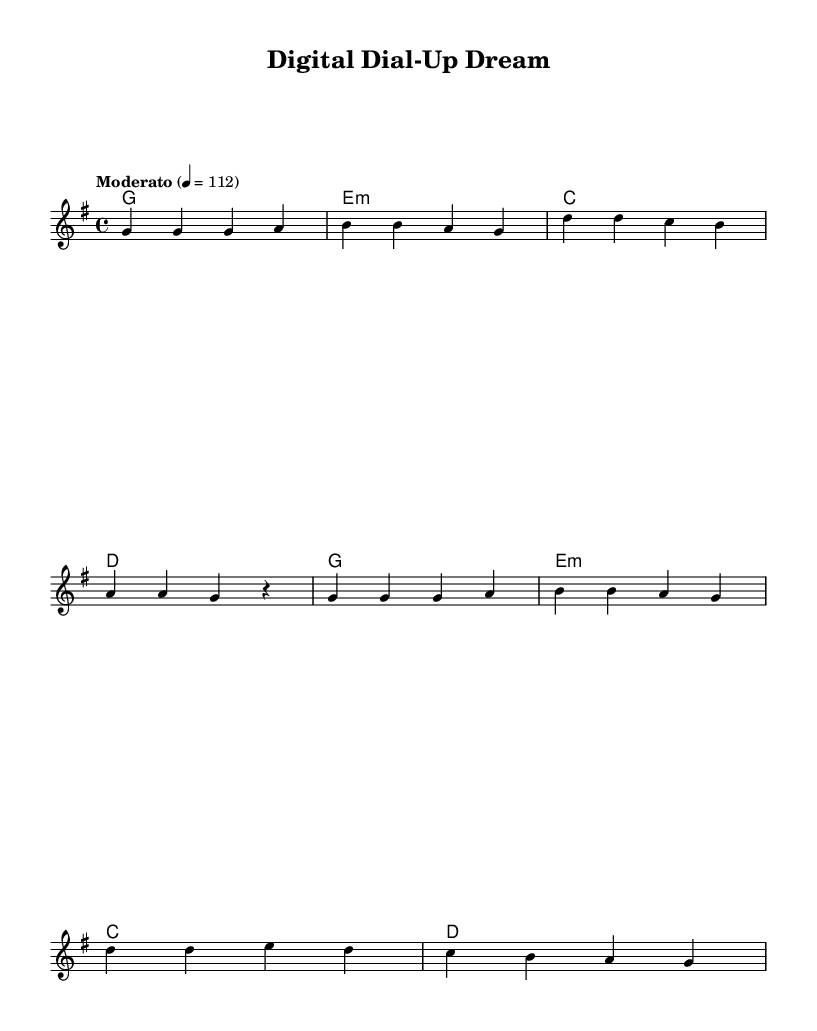What is the key signature of this music? The key signature is G major, which has one sharp (F#). This can be identified by looking at the key signature indicated at the beginning of the staff.
Answer: G major What is the time signature of this music? The time signature is 4/4, which can be seen at the beginning of the staff, indicating four beats per measure with a quarter note getting one beat.
Answer: 4/4 What is the tempo marking for this piece? The tempo marking is "Moderato," which indicates a moderate speed of the piece. This is also indicated above the staff.
Answer: Moderato How many measures are in the melody? There are 8 measures in the melody, as indicated by the grouping of notes and rests throughout the staff. Each measure is separated by vertical lines.
Answer: 8 Which chord is played in the first measure? The chord played in the first measure is G major, as indicated by the chord names placed above the staff. This can be confirmed by recognizing the root note and the notes of the chord itself.
Answer: G How does the harmony relate to the melody at measure five? In measure five, the melody continues with G notes, while the harmony also accents G major, creating a strong tonal relationship. The harmony supports the melody by providing the same root structure.
Answer: G major What is the last note of the melody? The last note of the melody is a rest, indicating a pause in the music at the final position of the staff. This rest signifies the end of the melodic line.
Answer: rest 